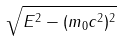<formula> <loc_0><loc_0><loc_500><loc_500>\sqrt { E ^ { 2 } - ( m _ { 0 } c ^ { 2 } ) ^ { 2 } }</formula> 